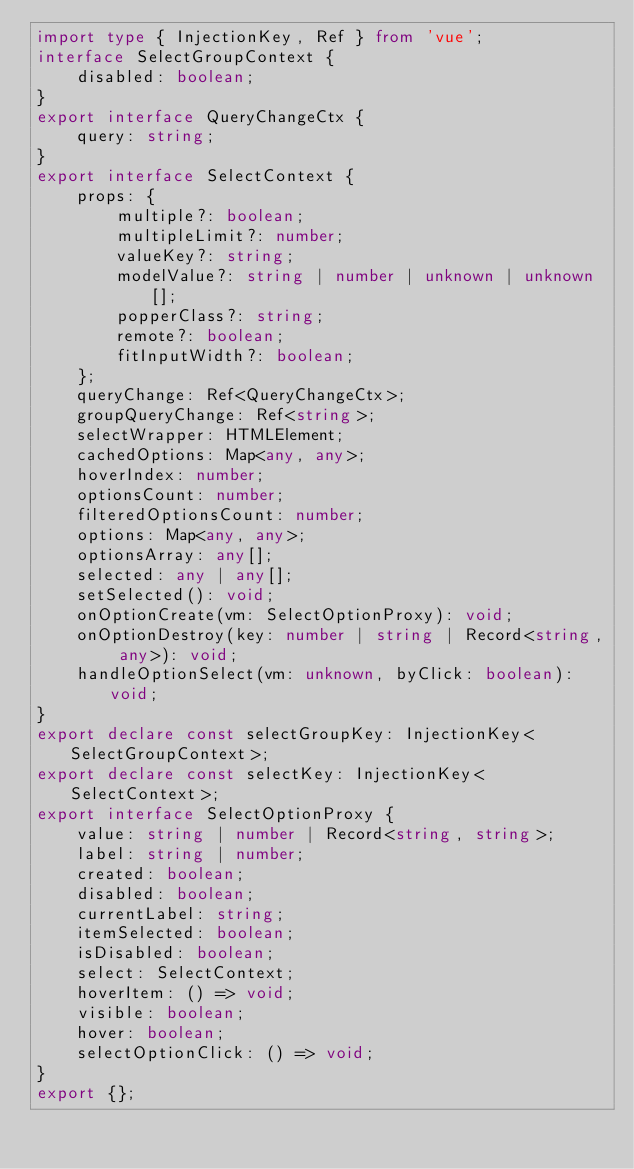<code> <loc_0><loc_0><loc_500><loc_500><_TypeScript_>import type { InjectionKey, Ref } from 'vue';
interface SelectGroupContext {
    disabled: boolean;
}
export interface QueryChangeCtx {
    query: string;
}
export interface SelectContext {
    props: {
        multiple?: boolean;
        multipleLimit?: number;
        valueKey?: string;
        modelValue?: string | number | unknown | unknown[];
        popperClass?: string;
        remote?: boolean;
        fitInputWidth?: boolean;
    };
    queryChange: Ref<QueryChangeCtx>;
    groupQueryChange: Ref<string>;
    selectWrapper: HTMLElement;
    cachedOptions: Map<any, any>;
    hoverIndex: number;
    optionsCount: number;
    filteredOptionsCount: number;
    options: Map<any, any>;
    optionsArray: any[];
    selected: any | any[];
    setSelected(): void;
    onOptionCreate(vm: SelectOptionProxy): void;
    onOptionDestroy(key: number | string | Record<string, any>): void;
    handleOptionSelect(vm: unknown, byClick: boolean): void;
}
export declare const selectGroupKey: InjectionKey<SelectGroupContext>;
export declare const selectKey: InjectionKey<SelectContext>;
export interface SelectOptionProxy {
    value: string | number | Record<string, string>;
    label: string | number;
    created: boolean;
    disabled: boolean;
    currentLabel: string;
    itemSelected: boolean;
    isDisabled: boolean;
    select: SelectContext;
    hoverItem: () => void;
    visible: boolean;
    hover: boolean;
    selectOptionClick: () => void;
}
export {};
</code> 